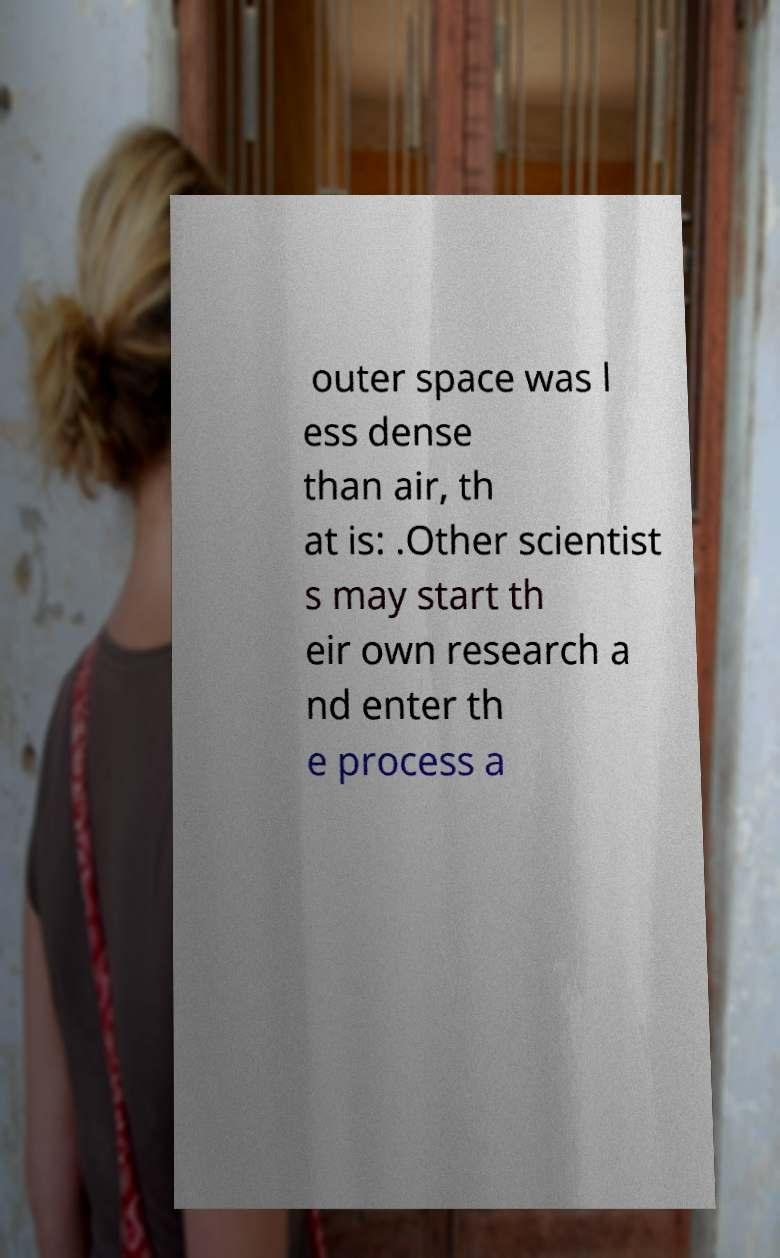Could you assist in decoding the text presented in this image and type it out clearly? outer space was l ess dense than air, th at is: .Other scientist s may start th eir own research a nd enter th e process a 